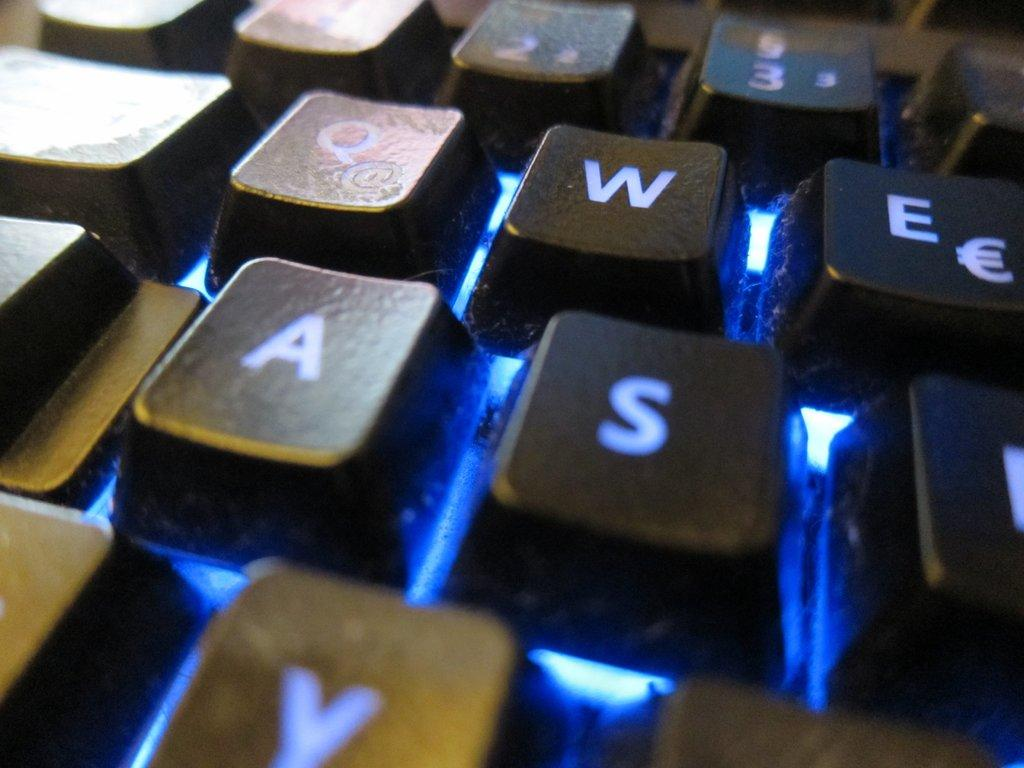<image>
Write a terse but informative summary of the picture. Buttons of a keyboard where you can see the letters Q, W, E, A and S. 